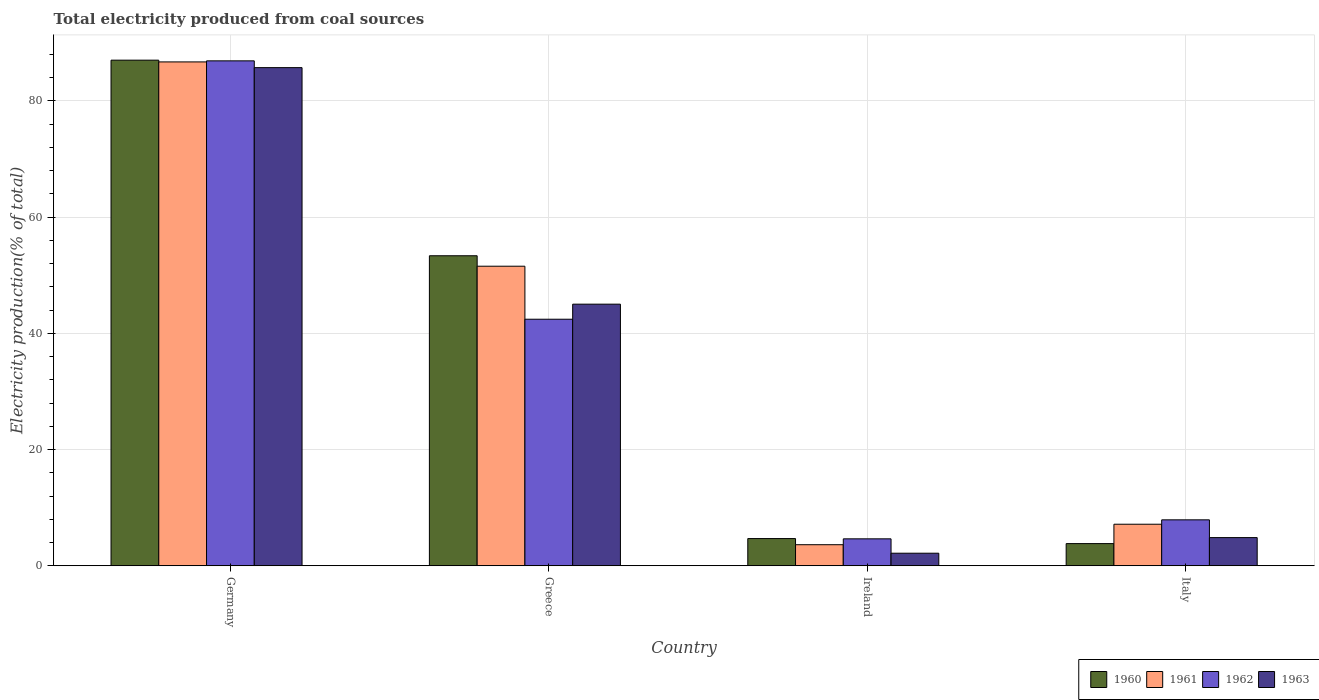How many different coloured bars are there?
Ensure brevity in your answer.  4. Are the number of bars per tick equal to the number of legend labels?
Keep it short and to the point. Yes. Are the number of bars on each tick of the X-axis equal?
Provide a succinct answer. Yes. How many bars are there on the 2nd tick from the right?
Provide a short and direct response. 4. What is the label of the 3rd group of bars from the left?
Ensure brevity in your answer.  Ireland. In how many cases, is the number of bars for a given country not equal to the number of legend labels?
Make the answer very short. 0. What is the total electricity produced in 1960 in Ireland?
Your response must be concise. 4.69. Across all countries, what is the maximum total electricity produced in 1961?
Your answer should be very brief. 86.73. Across all countries, what is the minimum total electricity produced in 1962?
Your response must be concise. 4.64. In which country was the total electricity produced in 1963 maximum?
Make the answer very short. Germany. In which country was the total electricity produced in 1961 minimum?
Ensure brevity in your answer.  Ireland. What is the total total electricity produced in 1963 in the graph?
Ensure brevity in your answer.  137.79. What is the difference between the total electricity produced in 1962 in Germany and that in Italy?
Provide a short and direct response. 79. What is the difference between the total electricity produced in 1960 in Ireland and the total electricity produced in 1963 in Germany?
Your answer should be very brief. -81.06. What is the average total electricity produced in 1962 per country?
Offer a terse response. 35.47. What is the difference between the total electricity produced of/in 1962 and total electricity produced of/in 1961 in Germany?
Offer a very short reply. 0.18. What is the ratio of the total electricity produced in 1962 in Germany to that in Greece?
Keep it short and to the point. 2.05. Is the difference between the total electricity produced in 1962 in Germany and Ireland greater than the difference between the total electricity produced in 1961 in Germany and Ireland?
Keep it short and to the point. No. What is the difference between the highest and the second highest total electricity produced in 1960?
Ensure brevity in your answer.  -48.68. What is the difference between the highest and the lowest total electricity produced in 1962?
Offer a very short reply. 82.27. In how many countries, is the total electricity produced in 1962 greater than the average total electricity produced in 1962 taken over all countries?
Offer a terse response. 2. Is it the case that in every country, the sum of the total electricity produced in 1960 and total electricity produced in 1963 is greater than the sum of total electricity produced in 1962 and total electricity produced in 1961?
Offer a terse response. No. What does the 3rd bar from the right in Ireland represents?
Ensure brevity in your answer.  1961. How many bars are there?
Offer a very short reply. 16. How many countries are there in the graph?
Make the answer very short. 4. Are the values on the major ticks of Y-axis written in scientific E-notation?
Give a very brief answer. No. Where does the legend appear in the graph?
Offer a terse response. Bottom right. What is the title of the graph?
Provide a succinct answer. Total electricity produced from coal sources. Does "2013" appear as one of the legend labels in the graph?
Make the answer very short. No. What is the Electricity production(% of total) in 1960 in Germany?
Your answer should be very brief. 87.03. What is the Electricity production(% of total) of 1961 in Germany?
Give a very brief answer. 86.73. What is the Electricity production(% of total) in 1962 in Germany?
Your answer should be very brief. 86.91. What is the Electricity production(% of total) of 1963 in Germany?
Your answer should be very brief. 85.74. What is the Electricity production(% of total) of 1960 in Greece?
Provide a short and direct response. 53.36. What is the Electricity production(% of total) in 1961 in Greece?
Make the answer very short. 51.56. What is the Electricity production(% of total) in 1962 in Greece?
Ensure brevity in your answer.  42.44. What is the Electricity production(% of total) in 1963 in Greece?
Give a very brief answer. 45.03. What is the Electricity production(% of total) in 1960 in Ireland?
Your answer should be very brief. 4.69. What is the Electricity production(% of total) in 1961 in Ireland?
Your answer should be very brief. 3.63. What is the Electricity production(% of total) in 1962 in Ireland?
Provide a succinct answer. 4.64. What is the Electricity production(% of total) in 1963 in Ireland?
Your answer should be very brief. 2.16. What is the Electricity production(% of total) of 1960 in Italy?
Give a very brief answer. 3.82. What is the Electricity production(% of total) of 1961 in Italy?
Offer a terse response. 7.15. What is the Electricity production(% of total) in 1962 in Italy?
Provide a short and direct response. 7.91. What is the Electricity production(% of total) in 1963 in Italy?
Provide a succinct answer. 4.85. Across all countries, what is the maximum Electricity production(% of total) in 1960?
Make the answer very short. 87.03. Across all countries, what is the maximum Electricity production(% of total) of 1961?
Provide a short and direct response. 86.73. Across all countries, what is the maximum Electricity production(% of total) of 1962?
Your answer should be very brief. 86.91. Across all countries, what is the maximum Electricity production(% of total) of 1963?
Provide a succinct answer. 85.74. Across all countries, what is the minimum Electricity production(% of total) of 1960?
Provide a short and direct response. 3.82. Across all countries, what is the minimum Electricity production(% of total) in 1961?
Offer a very short reply. 3.63. Across all countries, what is the minimum Electricity production(% of total) of 1962?
Provide a succinct answer. 4.64. Across all countries, what is the minimum Electricity production(% of total) in 1963?
Give a very brief answer. 2.16. What is the total Electricity production(% of total) in 1960 in the graph?
Keep it short and to the point. 148.9. What is the total Electricity production(% of total) of 1961 in the graph?
Your answer should be compact. 149.07. What is the total Electricity production(% of total) of 1962 in the graph?
Give a very brief answer. 141.9. What is the total Electricity production(% of total) in 1963 in the graph?
Your response must be concise. 137.79. What is the difference between the Electricity production(% of total) in 1960 in Germany and that in Greece?
Make the answer very short. 33.67. What is the difference between the Electricity production(% of total) of 1961 in Germany and that in Greece?
Your answer should be compact. 35.16. What is the difference between the Electricity production(% of total) of 1962 in Germany and that in Greece?
Give a very brief answer. 44.47. What is the difference between the Electricity production(% of total) in 1963 in Germany and that in Greece?
Make the answer very short. 40.71. What is the difference between the Electricity production(% of total) in 1960 in Germany and that in Ireland?
Offer a terse response. 82.34. What is the difference between the Electricity production(% of total) in 1961 in Germany and that in Ireland?
Provide a short and direct response. 83.1. What is the difference between the Electricity production(% of total) in 1962 in Germany and that in Ireland?
Make the answer very short. 82.27. What is the difference between the Electricity production(% of total) in 1963 in Germany and that in Ireland?
Provide a short and direct response. 83.58. What is the difference between the Electricity production(% of total) of 1960 in Germany and that in Italy?
Provide a succinct answer. 83.21. What is the difference between the Electricity production(% of total) in 1961 in Germany and that in Italy?
Offer a very short reply. 79.57. What is the difference between the Electricity production(% of total) in 1962 in Germany and that in Italy?
Provide a short and direct response. 79. What is the difference between the Electricity production(% of total) in 1963 in Germany and that in Italy?
Ensure brevity in your answer.  80.89. What is the difference between the Electricity production(% of total) of 1960 in Greece and that in Ireland?
Your answer should be very brief. 48.68. What is the difference between the Electricity production(% of total) of 1961 in Greece and that in Ireland?
Your response must be concise. 47.93. What is the difference between the Electricity production(% of total) in 1962 in Greece and that in Ireland?
Ensure brevity in your answer.  37.8. What is the difference between the Electricity production(% of total) in 1963 in Greece and that in Ireland?
Your response must be concise. 42.87. What is the difference between the Electricity production(% of total) of 1960 in Greece and that in Italy?
Your answer should be compact. 49.54. What is the difference between the Electricity production(% of total) in 1961 in Greece and that in Italy?
Ensure brevity in your answer.  44.41. What is the difference between the Electricity production(% of total) in 1962 in Greece and that in Italy?
Your response must be concise. 34.53. What is the difference between the Electricity production(% of total) in 1963 in Greece and that in Italy?
Your response must be concise. 40.18. What is the difference between the Electricity production(% of total) in 1960 in Ireland and that in Italy?
Keep it short and to the point. 0.87. What is the difference between the Electricity production(% of total) in 1961 in Ireland and that in Italy?
Your answer should be compact. -3.53. What is the difference between the Electricity production(% of total) in 1962 in Ireland and that in Italy?
Keep it short and to the point. -3.27. What is the difference between the Electricity production(% of total) in 1963 in Ireland and that in Italy?
Offer a terse response. -2.69. What is the difference between the Electricity production(% of total) in 1960 in Germany and the Electricity production(% of total) in 1961 in Greece?
Provide a succinct answer. 35.47. What is the difference between the Electricity production(% of total) of 1960 in Germany and the Electricity production(% of total) of 1962 in Greece?
Your answer should be compact. 44.59. What is the difference between the Electricity production(% of total) of 1960 in Germany and the Electricity production(% of total) of 1963 in Greece?
Offer a very short reply. 42. What is the difference between the Electricity production(% of total) of 1961 in Germany and the Electricity production(% of total) of 1962 in Greece?
Offer a terse response. 44.29. What is the difference between the Electricity production(% of total) in 1961 in Germany and the Electricity production(% of total) in 1963 in Greece?
Give a very brief answer. 41.69. What is the difference between the Electricity production(% of total) in 1962 in Germany and the Electricity production(% of total) in 1963 in Greece?
Make the answer very short. 41.88. What is the difference between the Electricity production(% of total) of 1960 in Germany and the Electricity production(% of total) of 1961 in Ireland?
Ensure brevity in your answer.  83.4. What is the difference between the Electricity production(% of total) of 1960 in Germany and the Electricity production(% of total) of 1962 in Ireland?
Offer a very short reply. 82.39. What is the difference between the Electricity production(% of total) of 1960 in Germany and the Electricity production(% of total) of 1963 in Ireland?
Offer a very short reply. 84.86. What is the difference between the Electricity production(% of total) of 1961 in Germany and the Electricity production(% of total) of 1962 in Ireland?
Your answer should be very brief. 82.08. What is the difference between the Electricity production(% of total) in 1961 in Germany and the Electricity production(% of total) in 1963 in Ireland?
Provide a short and direct response. 84.56. What is the difference between the Electricity production(% of total) in 1962 in Germany and the Electricity production(% of total) in 1963 in Ireland?
Your answer should be very brief. 84.74. What is the difference between the Electricity production(% of total) in 1960 in Germany and the Electricity production(% of total) in 1961 in Italy?
Your response must be concise. 79.87. What is the difference between the Electricity production(% of total) in 1960 in Germany and the Electricity production(% of total) in 1962 in Italy?
Keep it short and to the point. 79.12. What is the difference between the Electricity production(% of total) of 1960 in Germany and the Electricity production(% of total) of 1963 in Italy?
Offer a very short reply. 82.18. What is the difference between the Electricity production(% of total) in 1961 in Germany and the Electricity production(% of total) in 1962 in Italy?
Ensure brevity in your answer.  78.82. What is the difference between the Electricity production(% of total) of 1961 in Germany and the Electricity production(% of total) of 1963 in Italy?
Ensure brevity in your answer.  81.87. What is the difference between the Electricity production(% of total) in 1962 in Germany and the Electricity production(% of total) in 1963 in Italy?
Provide a short and direct response. 82.06. What is the difference between the Electricity production(% of total) in 1960 in Greece and the Electricity production(% of total) in 1961 in Ireland?
Offer a terse response. 49.73. What is the difference between the Electricity production(% of total) in 1960 in Greece and the Electricity production(% of total) in 1962 in Ireland?
Your response must be concise. 48.72. What is the difference between the Electricity production(% of total) of 1960 in Greece and the Electricity production(% of total) of 1963 in Ireland?
Your response must be concise. 51.2. What is the difference between the Electricity production(% of total) of 1961 in Greece and the Electricity production(% of total) of 1962 in Ireland?
Give a very brief answer. 46.92. What is the difference between the Electricity production(% of total) of 1961 in Greece and the Electricity production(% of total) of 1963 in Ireland?
Your response must be concise. 49.4. What is the difference between the Electricity production(% of total) of 1962 in Greece and the Electricity production(% of total) of 1963 in Ireland?
Offer a terse response. 40.27. What is the difference between the Electricity production(% of total) of 1960 in Greece and the Electricity production(% of total) of 1961 in Italy?
Your answer should be compact. 46.21. What is the difference between the Electricity production(% of total) in 1960 in Greece and the Electricity production(% of total) in 1962 in Italy?
Offer a terse response. 45.45. What is the difference between the Electricity production(% of total) of 1960 in Greece and the Electricity production(% of total) of 1963 in Italy?
Make the answer very short. 48.51. What is the difference between the Electricity production(% of total) in 1961 in Greece and the Electricity production(% of total) in 1962 in Italy?
Provide a succinct answer. 43.65. What is the difference between the Electricity production(% of total) in 1961 in Greece and the Electricity production(% of total) in 1963 in Italy?
Provide a short and direct response. 46.71. What is the difference between the Electricity production(% of total) in 1962 in Greece and the Electricity production(% of total) in 1963 in Italy?
Offer a very short reply. 37.59. What is the difference between the Electricity production(% of total) of 1960 in Ireland and the Electricity production(% of total) of 1961 in Italy?
Your answer should be very brief. -2.47. What is the difference between the Electricity production(% of total) in 1960 in Ireland and the Electricity production(% of total) in 1962 in Italy?
Ensure brevity in your answer.  -3.22. What is the difference between the Electricity production(% of total) in 1960 in Ireland and the Electricity production(% of total) in 1963 in Italy?
Your response must be concise. -0.17. What is the difference between the Electricity production(% of total) of 1961 in Ireland and the Electricity production(% of total) of 1962 in Italy?
Give a very brief answer. -4.28. What is the difference between the Electricity production(% of total) in 1961 in Ireland and the Electricity production(% of total) in 1963 in Italy?
Ensure brevity in your answer.  -1.22. What is the difference between the Electricity production(% of total) in 1962 in Ireland and the Electricity production(% of total) in 1963 in Italy?
Keep it short and to the point. -0.21. What is the average Electricity production(% of total) of 1960 per country?
Give a very brief answer. 37.22. What is the average Electricity production(% of total) in 1961 per country?
Provide a succinct answer. 37.27. What is the average Electricity production(% of total) of 1962 per country?
Offer a terse response. 35.47. What is the average Electricity production(% of total) in 1963 per country?
Your answer should be very brief. 34.45. What is the difference between the Electricity production(% of total) in 1960 and Electricity production(% of total) in 1961 in Germany?
Your response must be concise. 0.3. What is the difference between the Electricity production(% of total) in 1960 and Electricity production(% of total) in 1962 in Germany?
Keep it short and to the point. 0.12. What is the difference between the Electricity production(% of total) of 1960 and Electricity production(% of total) of 1963 in Germany?
Give a very brief answer. 1.29. What is the difference between the Electricity production(% of total) of 1961 and Electricity production(% of total) of 1962 in Germany?
Your answer should be very brief. -0.18. What is the difference between the Electricity production(% of total) in 1961 and Electricity production(% of total) in 1963 in Germany?
Make the answer very short. 0.98. What is the difference between the Electricity production(% of total) of 1960 and Electricity production(% of total) of 1961 in Greece?
Offer a terse response. 1.8. What is the difference between the Electricity production(% of total) of 1960 and Electricity production(% of total) of 1962 in Greece?
Offer a terse response. 10.92. What is the difference between the Electricity production(% of total) of 1960 and Electricity production(% of total) of 1963 in Greece?
Make the answer very short. 8.33. What is the difference between the Electricity production(% of total) in 1961 and Electricity production(% of total) in 1962 in Greece?
Provide a succinct answer. 9.12. What is the difference between the Electricity production(% of total) of 1961 and Electricity production(% of total) of 1963 in Greece?
Provide a succinct answer. 6.53. What is the difference between the Electricity production(% of total) of 1962 and Electricity production(% of total) of 1963 in Greece?
Your answer should be very brief. -2.59. What is the difference between the Electricity production(% of total) of 1960 and Electricity production(% of total) of 1961 in Ireland?
Your answer should be compact. 1.06. What is the difference between the Electricity production(% of total) of 1960 and Electricity production(% of total) of 1962 in Ireland?
Provide a succinct answer. 0.05. What is the difference between the Electricity production(% of total) in 1960 and Electricity production(% of total) in 1963 in Ireland?
Provide a short and direct response. 2.52. What is the difference between the Electricity production(% of total) in 1961 and Electricity production(% of total) in 1962 in Ireland?
Your response must be concise. -1.01. What is the difference between the Electricity production(% of total) in 1961 and Electricity production(% of total) in 1963 in Ireland?
Your answer should be compact. 1.46. What is the difference between the Electricity production(% of total) in 1962 and Electricity production(% of total) in 1963 in Ireland?
Offer a terse response. 2.48. What is the difference between the Electricity production(% of total) of 1960 and Electricity production(% of total) of 1961 in Italy?
Ensure brevity in your answer.  -3.34. What is the difference between the Electricity production(% of total) in 1960 and Electricity production(% of total) in 1962 in Italy?
Provide a short and direct response. -4.09. What is the difference between the Electricity production(% of total) in 1960 and Electricity production(% of total) in 1963 in Italy?
Ensure brevity in your answer.  -1.03. What is the difference between the Electricity production(% of total) in 1961 and Electricity production(% of total) in 1962 in Italy?
Provide a short and direct response. -0.75. What is the difference between the Electricity production(% of total) in 1961 and Electricity production(% of total) in 1963 in Italy?
Ensure brevity in your answer.  2.3. What is the difference between the Electricity production(% of total) of 1962 and Electricity production(% of total) of 1963 in Italy?
Offer a terse response. 3.06. What is the ratio of the Electricity production(% of total) of 1960 in Germany to that in Greece?
Provide a short and direct response. 1.63. What is the ratio of the Electricity production(% of total) of 1961 in Germany to that in Greece?
Give a very brief answer. 1.68. What is the ratio of the Electricity production(% of total) in 1962 in Germany to that in Greece?
Give a very brief answer. 2.05. What is the ratio of the Electricity production(% of total) in 1963 in Germany to that in Greece?
Ensure brevity in your answer.  1.9. What is the ratio of the Electricity production(% of total) of 1960 in Germany to that in Ireland?
Keep it short and to the point. 18.57. What is the ratio of the Electricity production(% of total) in 1961 in Germany to that in Ireland?
Provide a short and direct response. 23.9. What is the ratio of the Electricity production(% of total) of 1962 in Germany to that in Ireland?
Offer a terse response. 18.73. What is the ratio of the Electricity production(% of total) in 1963 in Germany to that in Ireland?
Ensure brevity in your answer.  39.6. What is the ratio of the Electricity production(% of total) of 1960 in Germany to that in Italy?
Make the answer very short. 22.79. What is the ratio of the Electricity production(% of total) in 1961 in Germany to that in Italy?
Provide a succinct answer. 12.12. What is the ratio of the Electricity production(% of total) in 1962 in Germany to that in Italy?
Offer a very short reply. 10.99. What is the ratio of the Electricity production(% of total) in 1963 in Germany to that in Italy?
Your answer should be very brief. 17.67. What is the ratio of the Electricity production(% of total) of 1960 in Greece to that in Ireland?
Make the answer very short. 11.39. What is the ratio of the Electricity production(% of total) in 1961 in Greece to that in Ireland?
Offer a very short reply. 14.21. What is the ratio of the Electricity production(% of total) in 1962 in Greece to that in Ireland?
Give a very brief answer. 9.14. What is the ratio of the Electricity production(% of total) in 1963 in Greece to that in Ireland?
Your answer should be compact. 20.8. What is the ratio of the Electricity production(% of total) in 1960 in Greece to that in Italy?
Offer a terse response. 13.97. What is the ratio of the Electricity production(% of total) in 1961 in Greece to that in Italy?
Provide a succinct answer. 7.21. What is the ratio of the Electricity production(% of total) in 1962 in Greece to that in Italy?
Your response must be concise. 5.37. What is the ratio of the Electricity production(% of total) of 1963 in Greece to that in Italy?
Your answer should be very brief. 9.28. What is the ratio of the Electricity production(% of total) in 1960 in Ireland to that in Italy?
Make the answer very short. 1.23. What is the ratio of the Electricity production(% of total) in 1961 in Ireland to that in Italy?
Ensure brevity in your answer.  0.51. What is the ratio of the Electricity production(% of total) of 1962 in Ireland to that in Italy?
Your answer should be compact. 0.59. What is the ratio of the Electricity production(% of total) of 1963 in Ireland to that in Italy?
Give a very brief answer. 0.45. What is the difference between the highest and the second highest Electricity production(% of total) of 1960?
Ensure brevity in your answer.  33.67. What is the difference between the highest and the second highest Electricity production(% of total) of 1961?
Offer a very short reply. 35.16. What is the difference between the highest and the second highest Electricity production(% of total) in 1962?
Your answer should be compact. 44.47. What is the difference between the highest and the second highest Electricity production(% of total) of 1963?
Offer a terse response. 40.71. What is the difference between the highest and the lowest Electricity production(% of total) in 1960?
Your answer should be very brief. 83.21. What is the difference between the highest and the lowest Electricity production(% of total) in 1961?
Keep it short and to the point. 83.1. What is the difference between the highest and the lowest Electricity production(% of total) in 1962?
Give a very brief answer. 82.27. What is the difference between the highest and the lowest Electricity production(% of total) in 1963?
Make the answer very short. 83.58. 